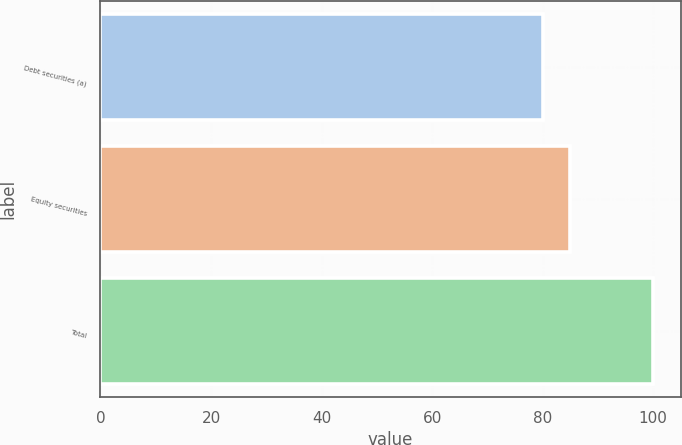<chart> <loc_0><loc_0><loc_500><loc_500><bar_chart><fcel>Debt securities (a)<fcel>Equity securities<fcel>Total<nl><fcel>80<fcel>85<fcel>100<nl></chart> 